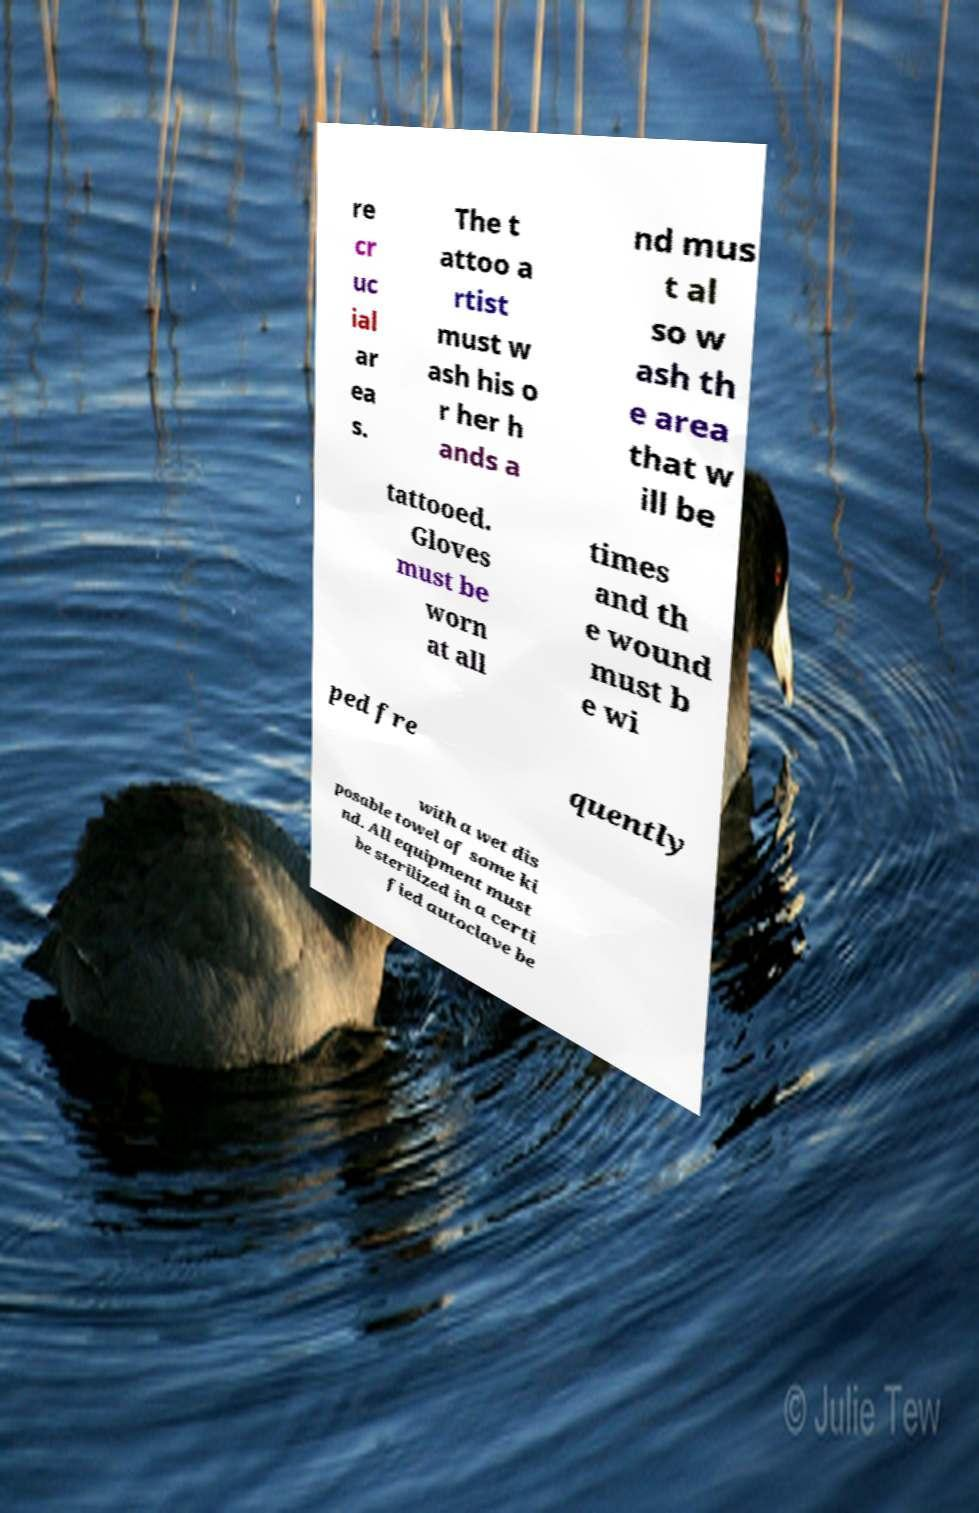What messages or text are displayed in this image? I need them in a readable, typed format. re cr uc ial ar ea s. The t attoo a rtist must w ash his o r her h ands a nd mus t al so w ash th e area that w ill be tattooed. Gloves must be worn at all times and th e wound must b e wi ped fre quently with a wet dis posable towel of some ki nd. All equipment must be sterilized in a certi fied autoclave be 